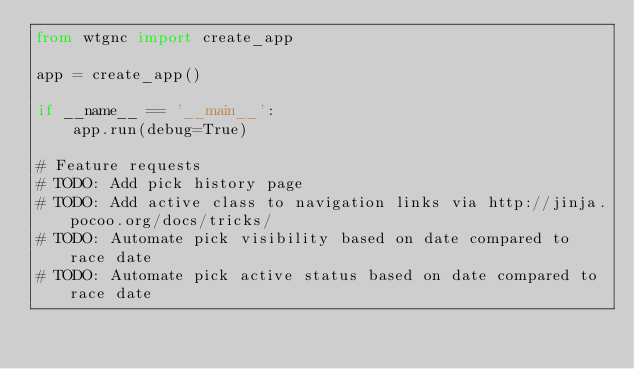<code> <loc_0><loc_0><loc_500><loc_500><_Python_>from wtgnc import create_app

app = create_app()

if __name__ == '__main__':
    app.run(debug=True)

# Feature requests
# TODO: Add pick history page
# TODO: Add active class to navigation links via http://jinja.pocoo.org/docs/tricks/
# TODO: Automate pick visibility based on date compared to race date
# TODO: Automate pick active status based on date compared to race date</code> 